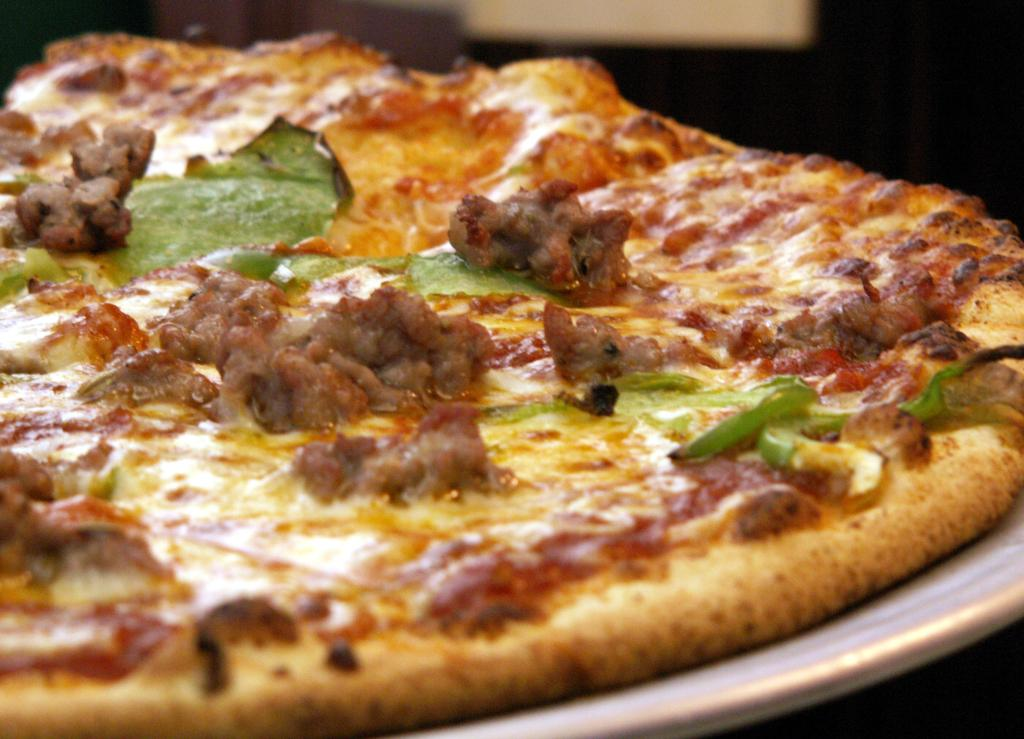What is on the plate that is visible in the image? The plate contains pizza. What color is the plate in the image? The plate is white. What type of wool is used to make the stocking in the image? There is no stocking or wool present in the image; it only features a white plate with pizza. 